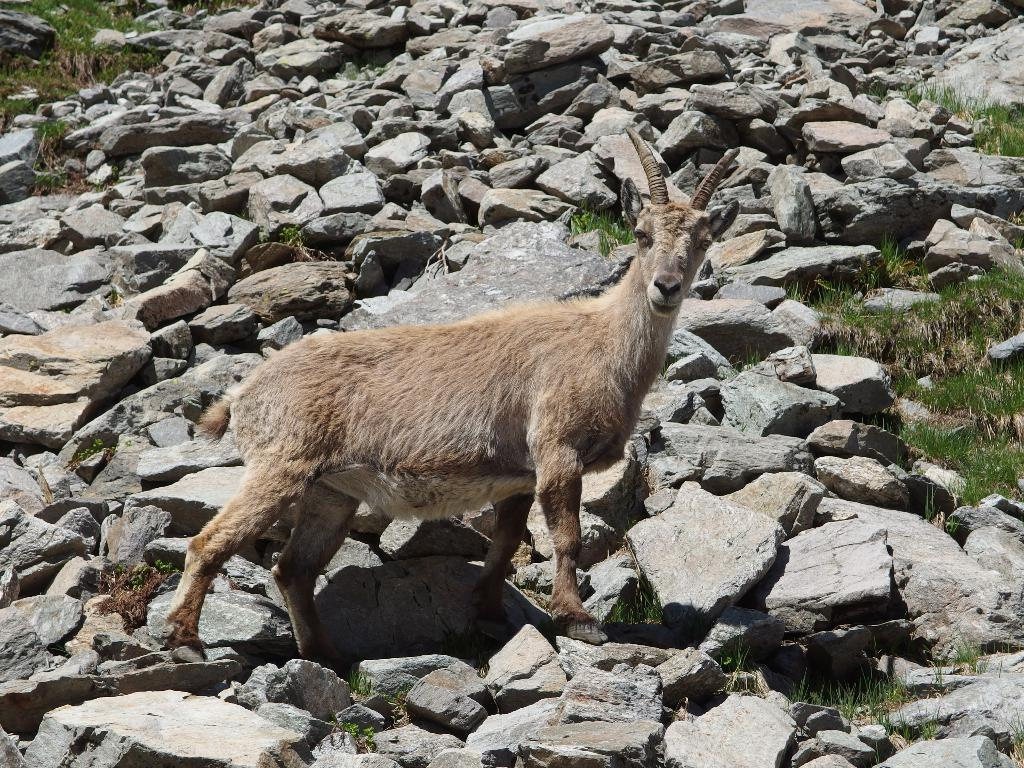What animal is present in the image? There is a goat in the image. What is the goat standing on? The goat is standing on stones. What type of vegetation can be seen in the background of the image? There is grass in the background of the image. What other objects are present in the background of the image? There are stones in the background of the image. What type of spark can be seen coming from the goat's horns in the image? There is no spark present in the image; the goat's horns are not emitting any sparks. 